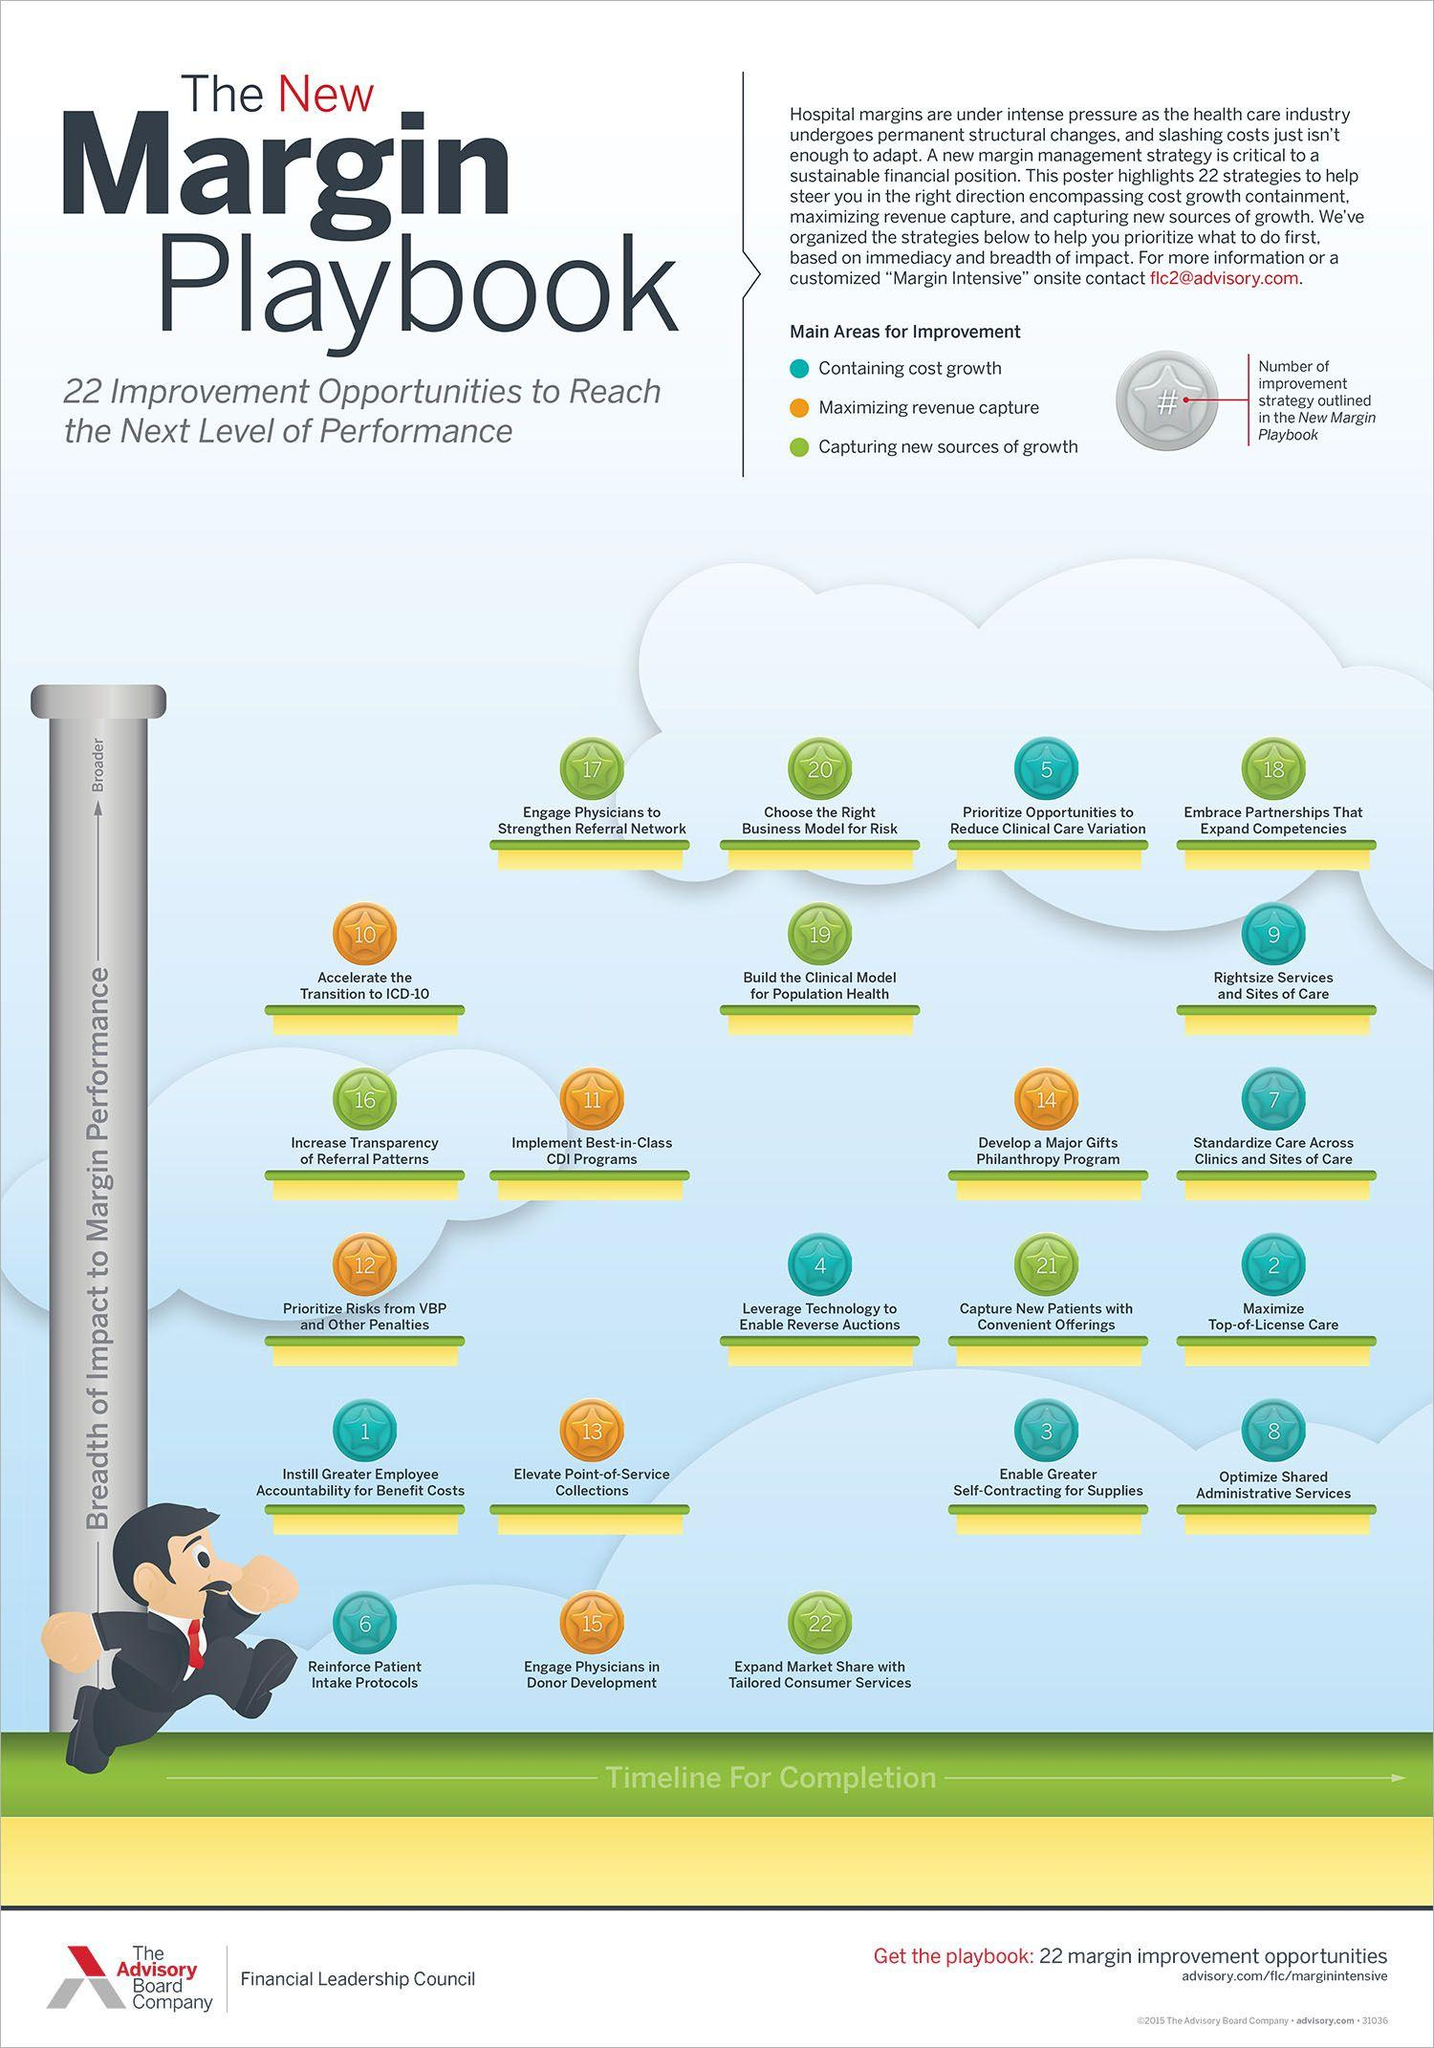Specify some key components in this picture. The Reinforce patient Intake protocols were one of the areas that underwent six improvements. In the past, the color orange was used to represent the concept of maximizing revenue capture. However, now it is known that the colors blue, green, and red were also used to represent this concept at certain points in time. A specific region or location received the same number of improvements as one, specifically in regards to increasing employee accountability for benefit costs. The area that received the greatest number of improvements was two. A specific location has 13 improvements in the area of elevate point-of-service collections. 